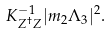<formula> <loc_0><loc_0><loc_500><loc_500>K _ { Z ^ { \dagger } Z } ^ { - 1 } | m _ { 2 } \Lambda _ { 3 } | ^ { 2 } .</formula> 